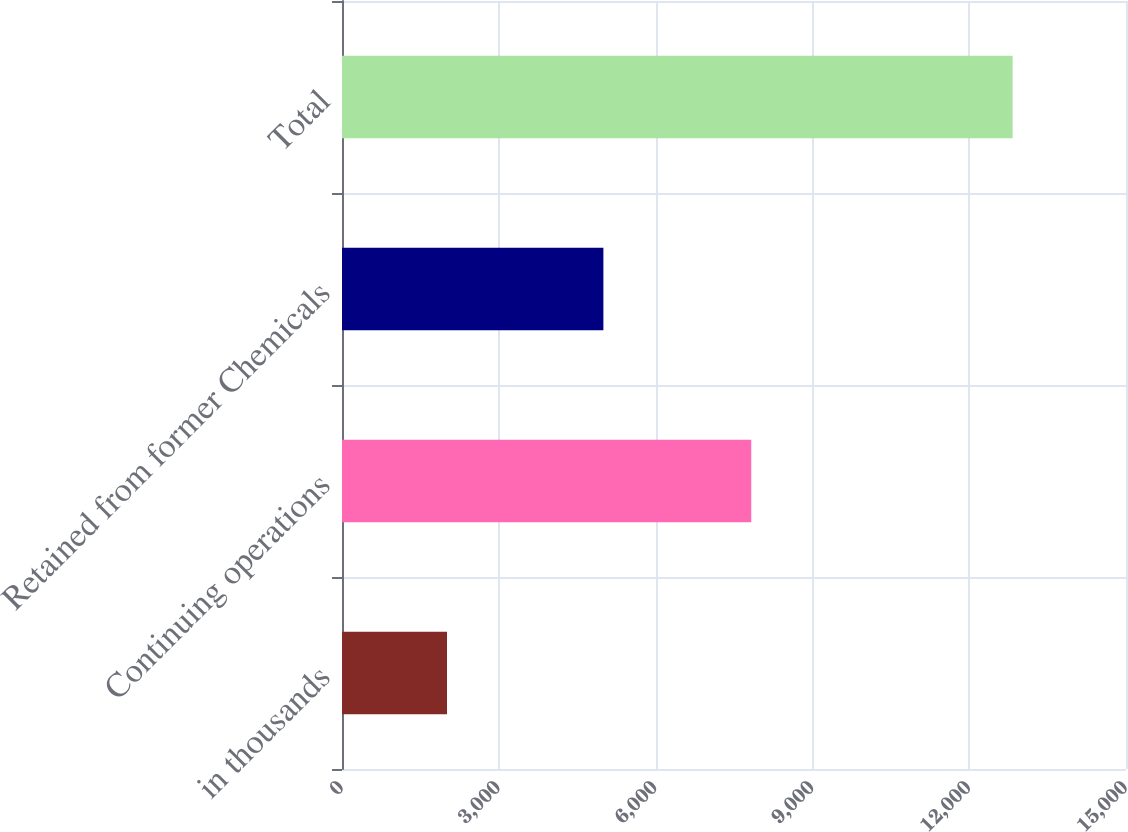Convert chart. <chart><loc_0><loc_0><loc_500><loc_500><bar_chart><fcel>in thousands<fcel>Continuing operations<fcel>Retained from former Chemicals<fcel>Total<nl><fcel>2009<fcel>7830<fcel>5001<fcel>12831<nl></chart> 